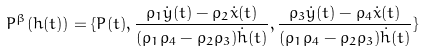<formula> <loc_0><loc_0><loc_500><loc_500>P ^ { \beta } ( h ( t ) ) = \{ P ( t ) , \frac { \varrho _ { 1 } \dot { y } ( t ) - \varrho _ { 2 } \dot { x } ( t ) } { ( \varrho _ { 1 } \varrho _ { 4 } - \varrho _ { 2 } \varrho _ { 3 } ) \dot { h } ( t ) } , \frac { \varrho _ { 3 } \dot { y } ( t ) - \varrho _ { 4 } \dot { x } ( t ) } { ( \varrho _ { 1 } \varrho _ { 4 } - \varrho _ { 2 } \varrho _ { 3 } ) \dot { h } ( t ) } \}</formula> 